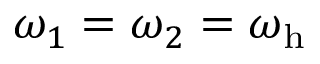Convert formula to latex. <formula><loc_0><loc_0><loc_500><loc_500>\omega _ { 1 } = \omega _ { 2 } = \omega _ { h }</formula> 